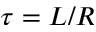Convert formula to latex. <formula><loc_0><loc_0><loc_500><loc_500>\tau = L / R</formula> 